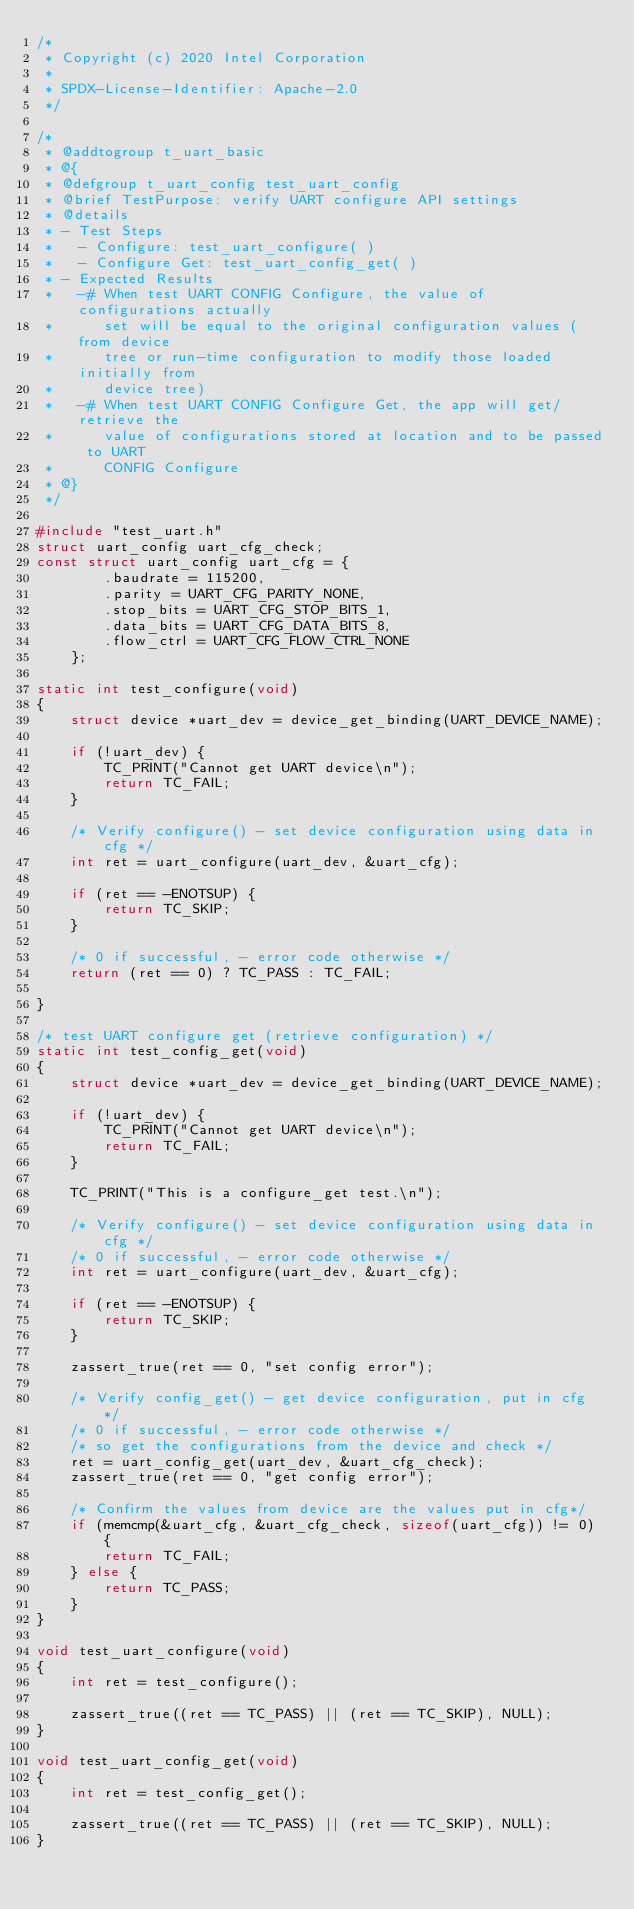Convert code to text. <code><loc_0><loc_0><loc_500><loc_500><_C_>/*
 * Copyright (c) 2020 Intel Corporation
 *
 * SPDX-License-Identifier: Apache-2.0
 */

/*
 * @addtogroup t_uart_basic
 * @{
 * @defgroup t_uart_config test_uart_config
 * @brief TestPurpose: verify UART configure API settings
 * @details
 * - Test Steps
 *   - Configure: test_uart_configure( )
 *   - Configure Get: test_uart_config_get( )
 * - Expected Results
 *   -# When test UART CONFIG Configure, the value of configurations actually
 *      set will be equal to the original configuration values (from device
 *      tree or run-time configuration to modify those loaded initially from
 *      device tree)
 *   -# When test UART CONFIG Configure Get, the app will get/retrieve the
 *      value of configurations stored at location and to be passed to UART
 *      CONFIG Configure
 * @}
 */

#include "test_uart.h"
struct uart_config uart_cfg_check;
const struct uart_config uart_cfg = {
		.baudrate = 115200,
		.parity = UART_CFG_PARITY_NONE,
		.stop_bits = UART_CFG_STOP_BITS_1,
		.data_bits = UART_CFG_DATA_BITS_8,
		.flow_ctrl = UART_CFG_FLOW_CTRL_NONE
	};

static int test_configure(void)
{
	struct device *uart_dev = device_get_binding(UART_DEVICE_NAME);

	if (!uart_dev) {
		TC_PRINT("Cannot get UART device\n");
		return TC_FAIL;
	}

	/* Verify configure() - set device configuration using data in cfg */
	int ret = uart_configure(uart_dev, &uart_cfg);

	if (ret == -ENOTSUP) {
		return TC_SKIP;
	}

	/* 0 if successful, - error code otherwise */
	return (ret == 0) ? TC_PASS : TC_FAIL;

}

/* test UART configure get (retrieve configuration) */
static int test_config_get(void)
{
	struct device *uart_dev = device_get_binding(UART_DEVICE_NAME);

	if (!uart_dev) {
		TC_PRINT("Cannot get UART device\n");
		return TC_FAIL;
	}

	TC_PRINT("This is a configure_get test.\n");

	/* Verify configure() - set device configuration using data in cfg */
	/* 0 if successful, - error code otherwise */
	int ret = uart_configure(uart_dev, &uart_cfg);

	if (ret == -ENOTSUP) {
		return TC_SKIP;
	}

	zassert_true(ret == 0, "set config error");

	/* Verify config_get() - get device configuration, put in cfg */
	/* 0 if successful, - error code otherwise */
	/* so get the configurations from the device and check */
	ret = uart_config_get(uart_dev, &uart_cfg_check);
	zassert_true(ret == 0, "get config error");

	/* Confirm the values from device are the values put in cfg*/
	if (memcmp(&uart_cfg, &uart_cfg_check, sizeof(uart_cfg)) != 0) {
		return TC_FAIL;
	} else {
		return TC_PASS;
	}
}

void test_uart_configure(void)
{
	int ret = test_configure();

	zassert_true((ret == TC_PASS) || (ret == TC_SKIP), NULL);
}

void test_uart_config_get(void)
{
	int ret = test_config_get();

	zassert_true((ret == TC_PASS) || (ret == TC_SKIP), NULL);
}
</code> 